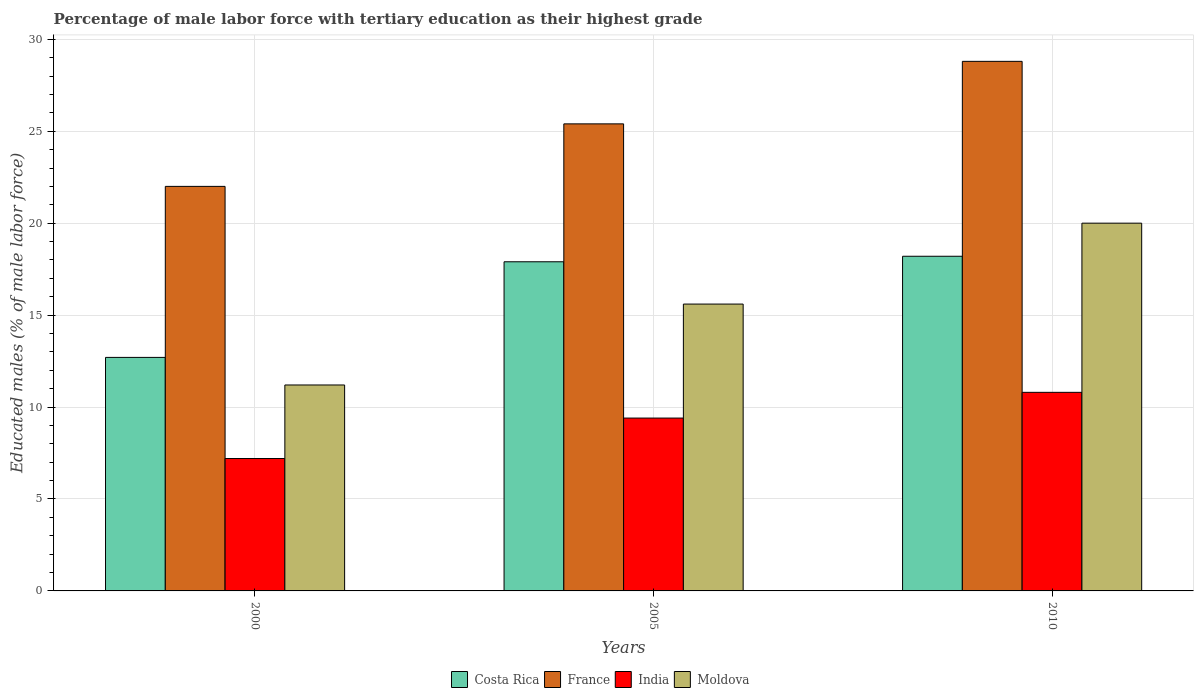How many different coloured bars are there?
Your answer should be compact. 4. How many groups of bars are there?
Offer a very short reply. 3. Are the number of bars on each tick of the X-axis equal?
Offer a very short reply. Yes. How many bars are there on the 1st tick from the left?
Ensure brevity in your answer.  4. In how many cases, is the number of bars for a given year not equal to the number of legend labels?
Provide a short and direct response. 0. What is the percentage of male labor force with tertiary education in France in 2005?
Your answer should be very brief. 25.4. Across all years, what is the maximum percentage of male labor force with tertiary education in Moldova?
Ensure brevity in your answer.  20. Across all years, what is the minimum percentage of male labor force with tertiary education in Moldova?
Offer a very short reply. 11.2. What is the total percentage of male labor force with tertiary education in Moldova in the graph?
Give a very brief answer. 46.8. What is the difference between the percentage of male labor force with tertiary education in Moldova in 2005 and that in 2010?
Provide a short and direct response. -4.4. What is the difference between the percentage of male labor force with tertiary education in Moldova in 2000 and the percentage of male labor force with tertiary education in France in 2010?
Your answer should be compact. -17.6. What is the average percentage of male labor force with tertiary education in Moldova per year?
Give a very brief answer. 15.6. In the year 2005, what is the difference between the percentage of male labor force with tertiary education in Moldova and percentage of male labor force with tertiary education in India?
Provide a short and direct response. 6.2. In how many years, is the percentage of male labor force with tertiary education in Moldova greater than 4 %?
Ensure brevity in your answer.  3. What is the ratio of the percentage of male labor force with tertiary education in France in 2000 to that in 2005?
Give a very brief answer. 0.87. Is the percentage of male labor force with tertiary education in Costa Rica in 2000 less than that in 2010?
Provide a short and direct response. Yes. What is the difference between the highest and the second highest percentage of male labor force with tertiary education in India?
Give a very brief answer. 1.4. What is the difference between the highest and the lowest percentage of male labor force with tertiary education in Moldova?
Ensure brevity in your answer.  8.8. In how many years, is the percentage of male labor force with tertiary education in Moldova greater than the average percentage of male labor force with tertiary education in Moldova taken over all years?
Make the answer very short. 2. Is the sum of the percentage of male labor force with tertiary education in India in 2005 and 2010 greater than the maximum percentage of male labor force with tertiary education in France across all years?
Your response must be concise. No. Is it the case that in every year, the sum of the percentage of male labor force with tertiary education in India and percentage of male labor force with tertiary education in Costa Rica is greater than the sum of percentage of male labor force with tertiary education in France and percentage of male labor force with tertiary education in Moldova?
Your answer should be very brief. Yes. What does the 4th bar from the left in 2010 represents?
Provide a succinct answer. Moldova. Are all the bars in the graph horizontal?
Your response must be concise. No. What is the difference between two consecutive major ticks on the Y-axis?
Your answer should be very brief. 5. Does the graph contain any zero values?
Offer a very short reply. No. How many legend labels are there?
Offer a terse response. 4. How are the legend labels stacked?
Your answer should be compact. Horizontal. What is the title of the graph?
Provide a short and direct response. Percentage of male labor force with tertiary education as their highest grade. Does "Tonga" appear as one of the legend labels in the graph?
Offer a terse response. No. What is the label or title of the Y-axis?
Ensure brevity in your answer.  Educated males (% of male labor force). What is the Educated males (% of male labor force) of Costa Rica in 2000?
Provide a succinct answer. 12.7. What is the Educated males (% of male labor force) of France in 2000?
Give a very brief answer. 22. What is the Educated males (% of male labor force) of India in 2000?
Keep it short and to the point. 7.2. What is the Educated males (% of male labor force) of Moldova in 2000?
Offer a very short reply. 11.2. What is the Educated males (% of male labor force) of Costa Rica in 2005?
Your response must be concise. 17.9. What is the Educated males (% of male labor force) of France in 2005?
Make the answer very short. 25.4. What is the Educated males (% of male labor force) in India in 2005?
Your answer should be very brief. 9.4. What is the Educated males (% of male labor force) of Moldova in 2005?
Your answer should be very brief. 15.6. What is the Educated males (% of male labor force) in Costa Rica in 2010?
Ensure brevity in your answer.  18.2. What is the Educated males (% of male labor force) in France in 2010?
Your answer should be compact. 28.8. What is the Educated males (% of male labor force) in India in 2010?
Provide a succinct answer. 10.8. Across all years, what is the maximum Educated males (% of male labor force) in Costa Rica?
Your answer should be compact. 18.2. Across all years, what is the maximum Educated males (% of male labor force) in France?
Provide a short and direct response. 28.8. Across all years, what is the maximum Educated males (% of male labor force) in India?
Your response must be concise. 10.8. Across all years, what is the minimum Educated males (% of male labor force) in Costa Rica?
Your answer should be compact. 12.7. Across all years, what is the minimum Educated males (% of male labor force) in France?
Your response must be concise. 22. Across all years, what is the minimum Educated males (% of male labor force) in India?
Your answer should be compact. 7.2. Across all years, what is the minimum Educated males (% of male labor force) of Moldova?
Offer a terse response. 11.2. What is the total Educated males (% of male labor force) of Costa Rica in the graph?
Ensure brevity in your answer.  48.8. What is the total Educated males (% of male labor force) in France in the graph?
Your answer should be very brief. 76.2. What is the total Educated males (% of male labor force) in India in the graph?
Keep it short and to the point. 27.4. What is the total Educated males (% of male labor force) of Moldova in the graph?
Offer a terse response. 46.8. What is the difference between the Educated males (% of male labor force) in India in 2000 and that in 2005?
Keep it short and to the point. -2.2. What is the difference between the Educated males (% of male labor force) in Costa Rica in 2000 and that in 2010?
Keep it short and to the point. -5.5. What is the difference between the Educated males (% of male labor force) of France in 2000 and that in 2010?
Offer a very short reply. -6.8. What is the difference between the Educated males (% of male labor force) of India in 2000 and that in 2010?
Your response must be concise. -3.6. What is the difference between the Educated males (% of male labor force) in Moldova in 2000 and that in 2010?
Your answer should be compact. -8.8. What is the difference between the Educated males (% of male labor force) in Costa Rica in 2005 and that in 2010?
Give a very brief answer. -0.3. What is the difference between the Educated males (% of male labor force) in France in 2005 and that in 2010?
Keep it short and to the point. -3.4. What is the difference between the Educated males (% of male labor force) of India in 2005 and that in 2010?
Ensure brevity in your answer.  -1.4. What is the difference between the Educated males (% of male labor force) in Costa Rica in 2000 and the Educated males (% of male labor force) in France in 2005?
Make the answer very short. -12.7. What is the difference between the Educated males (% of male labor force) in Costa Rica in 2000 and the Educated males (% of male labor force) in India in 2005?
Provide a short and direct response. 3.3. What is the difference between the Educated males (% of male labor force) of Costa Rica in 2000 and the Educated males (% of male labor force) of Moldova in 2005?
Make the answer very short. -2.9. What is the difference between the Educated males (% of male labor force) in France in 2000 and the Educated males (% of male labor force) in Moldova in 2005?
Your answer should be compact. 6.4. What is the difference between the Educated males (% of male labor force) in India in 2000 and the Educated males (% of male labor force) in Moldova in 2005?
Your answer should be very brief. -8.4. What is the difference between the Educated males (% of male labor force) of Costa Rica in 2000 and the Educated males (% of male labor force) of France in 2010?
Give a very brief answer. -16.1. What is the difference between the Educated males (% of male labor force) of France in 2000 and the Educated males (% of male labor force) of India in 2010?
Ensure brevity in your answer.  11.2. What is the difference between the Educated males (% of male labor force) of France in 2000 and the Educated males (% of male labor force) of Moldova in 2010?
Your answer should be very brief. 2. What is the difference between the Educated males (% of male labor force) in India in 2000 and the Educated males (% of male labor force) in Moldova in 2010?
Offer a terse response. -12.8. What is the difference between the Educated males (% of male labor force) of Costa Rica in 2005 and the Educated males (% of male labor force) of Moldova in 2010?
Your response must be concise. -2.1. What is the difference between the Educated males (% of male labor force) of France in 2005 and the Educated males (% of male labor force) of Moldova in 2010?
Keep it short and to the point. 5.4. What is the average Educated males (% of male labor force) in Costa Rica per year?
Your answer should be compact. 16.27. What is the average Educated males (% of male labor force) in France per year?
Give a very brief answer. 25.4. What is the average Educated males (% of male labor force) of India per year?
Give a very brief answer. 9.13. In the year 2000, what is the difference between the Educated males (% of male labor force) in Costa Rica and Educated males (% of male labor force) in France?
Your answer should be compact. -9.3. In the year 2000, what is the difference between the Educated males (% of male labor force) in Costa Rica and Educated males (% of male labor force) in India?
Ensure brevity in your answer.  5.5. In the year 2000, what is the difference between the Educated males (% of male labor force) in Costa Rica and Educated males (% of male labor force) in Moldova?
Make the answer very short. 1.5. In the year 2000, what is the difference between the Educated males (% of male labor force) of France and Educated males (% of male labor force) of India?
Offer a terse response. 14.8. In the year 2000, what is the difference between the Educated males (% of male labor force) of India and Educated males (% of male labor force) of Moldova?
Your answer should be compact. -4. In the year 2005, what is the difference between the Educated males (% of male labor force) in Costa Rica and Educated males (% of male labor force) in France?
Give a very brief answer. -7.5. In the year 2005, what is the difference between the Educated males (% of male labor force) of Costa Rica and Educated males (% of male labor force) of India?
Offer a very short reply. 8.5. In the year 2005, what is the difference between the Educated males (% of male labor force) in Costa Rica and Educated males (% of male labor force) in Moldova?
Ensure brevity in your answer.  2.3. In the year 2010, what is the difference between the Educated males (% of male labor force) in Costa Rica and Educated males (% of male labor force) in Moldova?
Give a very brief answer. -1.8. What is the ratio of the Educated males (% of male labor force) of Costa Rica in 2000 to that in 2005?
Your answer should be very brief. 0.71. What is the ratio of the Educated males (% of male labor force) of France in 2000 to that in 2005?
Offer a very short reply. 0.87. What is the ratio of the Educated males (% of male labor force) of India in 2000 to that in 2005?
Your response must be concise. 0.77. What is the ratio of the Educated males (% of male labor force) of Moldova in 2000 to that in 2005?
Make the answer very short. 0.72. What is the ratio of the Educated males (% of male labor force) in Costa Rica in 2000 to that in 2010?
Offer a very short reply. 0.7. What is the ratio of the Educated males (% of male labor force) in France in 2000 to that in 2010?
Offer a terse response. 0.76. What is the ratio of the Educated males (% of male labor force) in Moldova in 2000 to that in 2010?
Your response must be concise. 0.56. What is the ratio of the Educated males (% of male labor force) in Costa Rica in 2005 to that in 2010?
Provide a short and direct response. 0.98. What is the ratio of the Educated males (% of male labor force) in France in 2005 to that in 2010?
Your response must be concise. 0.88. What is the ratio of the Educated males (% of male labor force) of India in 2005 to that in 2010?
Your answer should be compact. 0.87. What is the ratio of the Educated males (% of male labor force) of Moldova in 2005 to that in 2010?
Your answer should be very brief. 0.78. What is the difference between the highest and the second highest Educated males (% of male labor force) of India?
Your answer should be compact. 1.4. What is the difference between the highest and the second highest Educated males (% of male labor force) in Moldova?
Offer a very short reply. 4.4. What is the difference between the highest and the lowest Educated males (% of male labor force) in France?
Give a very brief answer. 6.8. 